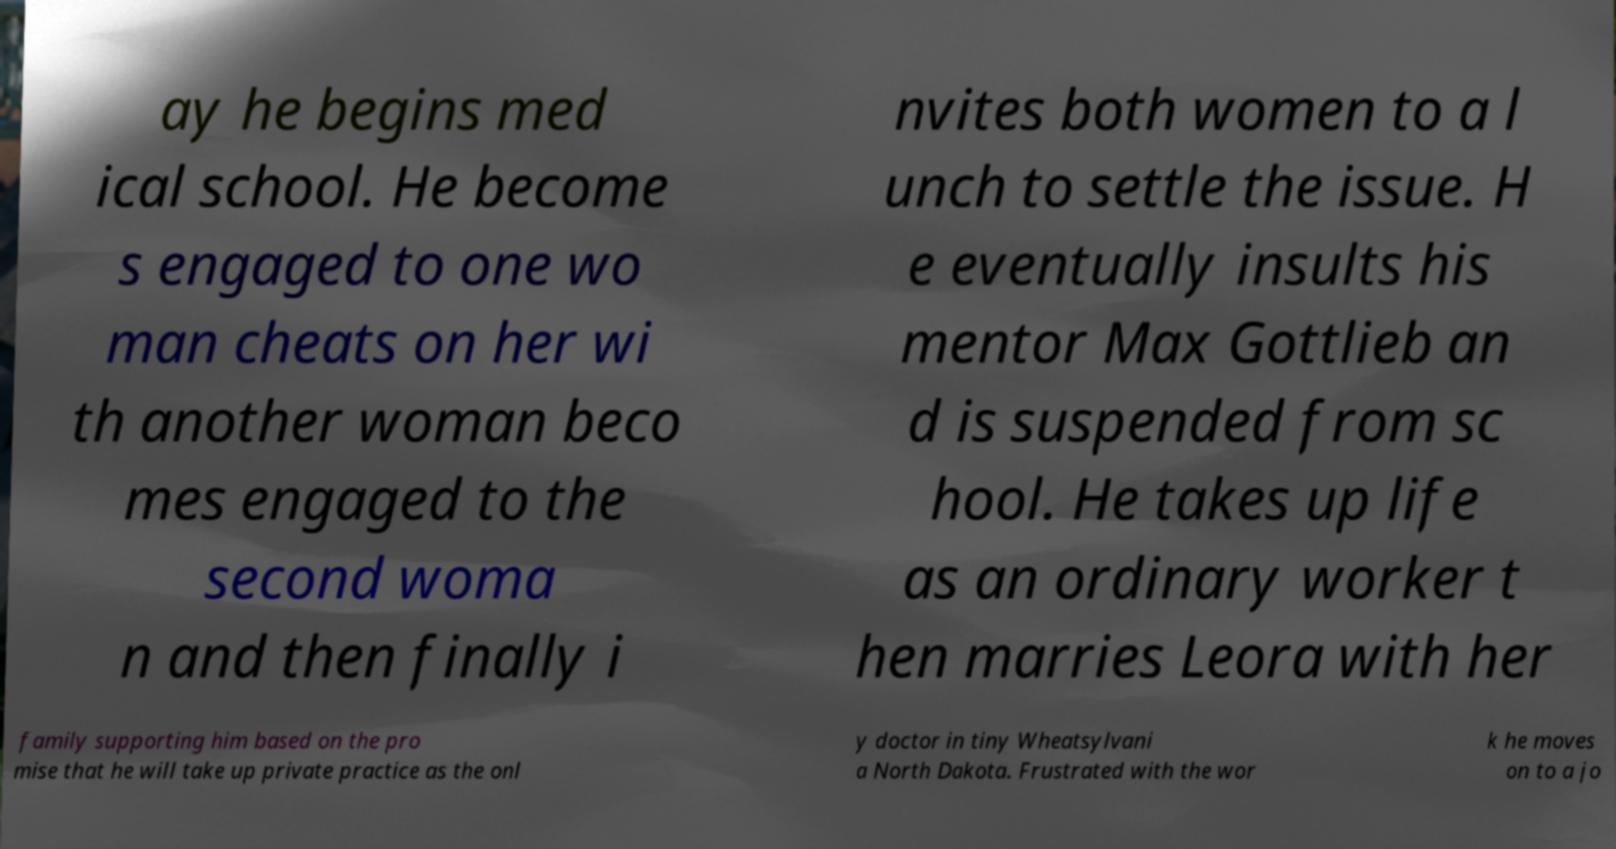I need the written content from this picture converted into text. Can you do that? ay he begins med ical school. He become s engaged to one wo man cheats on her wi th another woman beco mes engaged to the second woma n and then finally i nvites both women to a l unch to settle the issue. H e eventually insults his mentor Max Gottlieb an d is suspended from sc hool. He takes up life as an ordinary worker t hen marries Leora with her family supporting him based on the pro mise that he will take up private practice as the onl y doctor in tiny Wheatsylvani a North Dakota. Frustrated with the wor k he moves on to a jo 